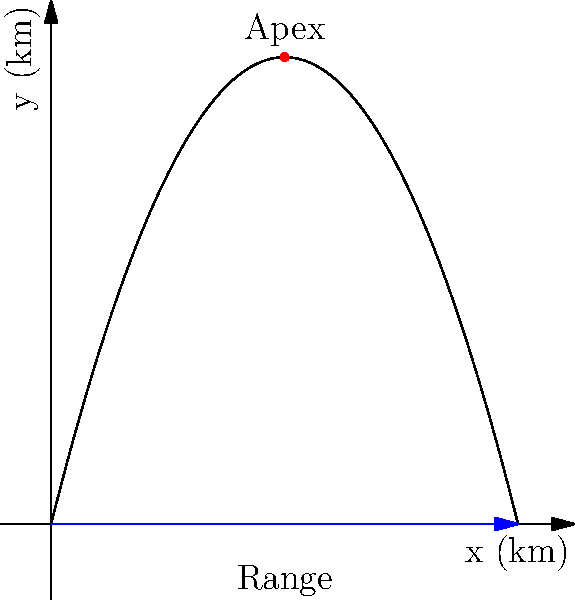In the latest mission of the Jupiter 2, the Robinson family needs to calculate the trajectory of their spacecraft for a safe landing. The path of the spacecraft follows a parabolic curve described by the equation $y = -0.5x^2 + 4x$, where $x$ and $y$ are measured in kilometers. What is the range (total horizontal distance) of the spacecraft's trajectory? To find the range of the spacecraft's trajectory, we need to follow these steps:

1) The range is the distance between the two points where the parabola intersects the x-axis. These points occur when $y = 0$.

2) Set up the equation:
   $0 = -0.5x^2 + 4x$

3) Rearrange the equation:
   $0.5x^2 - 4x = 0$

4) Factor out the common factor:
   $x(0.5x - 4) = 0$

5) Solve for x:
   $x = 0$ or $0.5x - 4 = 0$
   $x = 0$ or $x = 8$

6) The range is the distance between these two x-values:
   Range = $8 - 0 = 8$ km

Therefore, the total horizontal distance (range) of the spacecraft's trajectory is 8 kilometers.
Answer: 8 km 